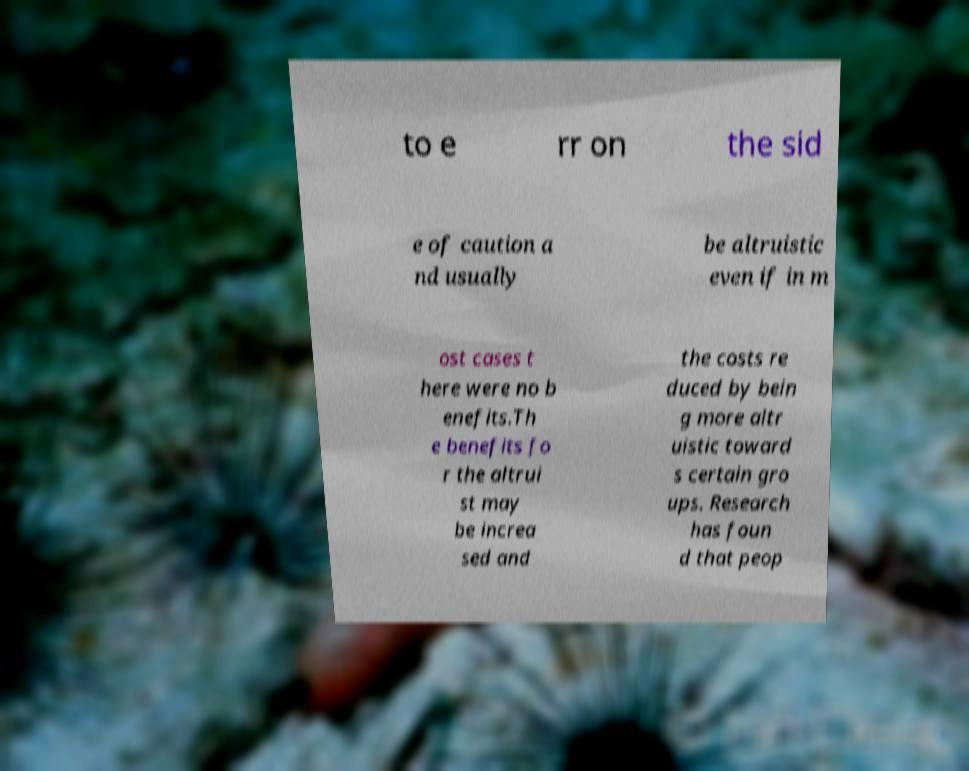For documentation purposes, I need the text within this image transcribed. Could you provide that? to e rr on the sid e of caution a nd usually be altruistic even if in m ost cases t here were no b enefits.Th e benefits fo r the altrui st may be increa sed and the costs re duced by bein g more altr uistic toward s certain gro ups. Research has foun d that peop 